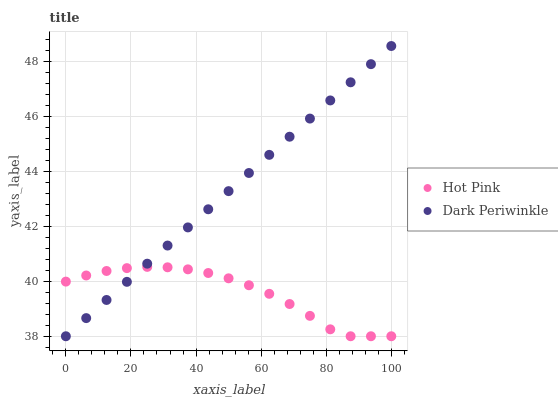Does Hot Pink have the minimum area under the curve?
Answer yes or no. Yes. Does Dark Periwinkle have the maximum area under the curve?
Answer yes or no. Yes. Does Dark Periwinkle have the minimum area under the curve?
Answer yes or no. No. Is Dark Periwinkle the smoothest?
Answer yes or no. Yes. Is Hot Pink the roughest?
Answer yes or no. Yes. Is Dark Periwinkle the roughest?
Answer yes or no. No. Does Hot Pink have the lowest value?
Answer yes or no. Yes. Does Dark Periwinkle have the highest value?
Answer yes or no. Yes. Does Hot Pink intersect Dark Periwinkle?
Answer yes or no. Yes. Is Hot Pink less than Dark Periwinkle?
Answer yes or no. No. Is Hot Pink greater than Dark Periwinkle?
Answer yes or no. No. 